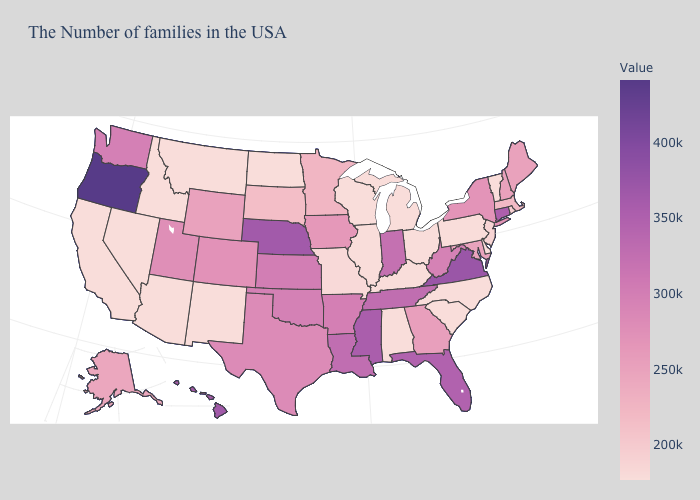Does Kentucky have a lower value than Florida?
Give a very brief answer. Yes. Among the states that border Iowa , which have the highest value?
Short answer required. Nebraska. Does Alaska have a higher value than Louisiana?
Be succinct. No. 